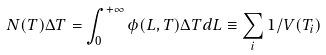<formula> <loc_0><loc_0><loc_500><loc_500>N ( T ) \Delta T = \int _ { 0 } ^ { + \infty } \phi ( L , T ) \Delta T d L \equiv \sum _ { i } 1 / V ( T _ { i } )</formula> 